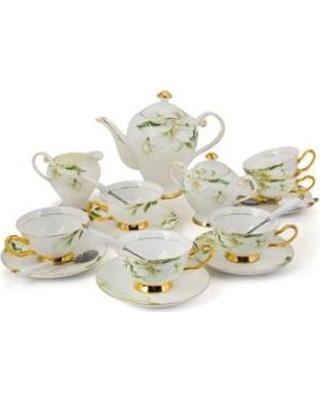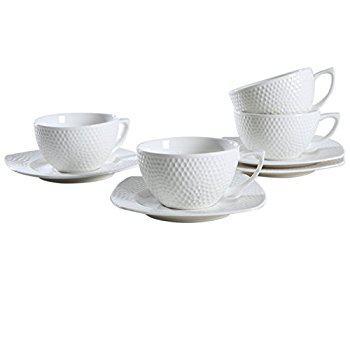The first image is the image on the left, the second image is the image on the right. For the images displayed, is the sentence "There is a teapot in one of the images." factually correct? Answer yes or no. Yes. 